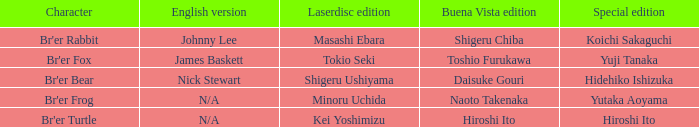What character is portrayed by koichi sakaguchi in the special edition? Br'er Rabbit. 